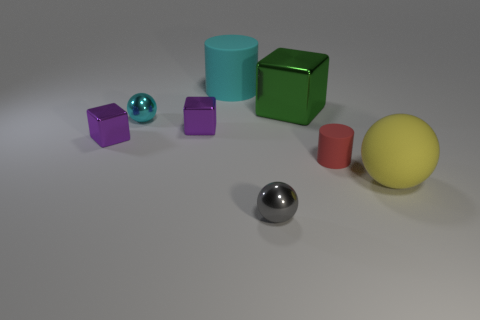Subtract all tiny shiny spheres. How many spheres are left? 1 Add 1 big yellow rubber things. How many objects exist? 9 Subtract all cyan cylinders. How many cylinders are left? 1 Subtract 1 cubes. How many cubes are left? 2 Subtract all yellow matte balls. Subtract all tiny red metal objects. How many objects are left? 7 Add 1 large cyan objects. How many large cyan objects are left? 2 Add 3 large cyan metal blocks. How many large cyan metal blocks exist? 3 Subtract 0 green cylinders. How many objects are left? 8 Subtract all spheres. How many objects are left? 5 Subtract all red blocks. Subtract all green cylinders. How many blocks are left? 3 